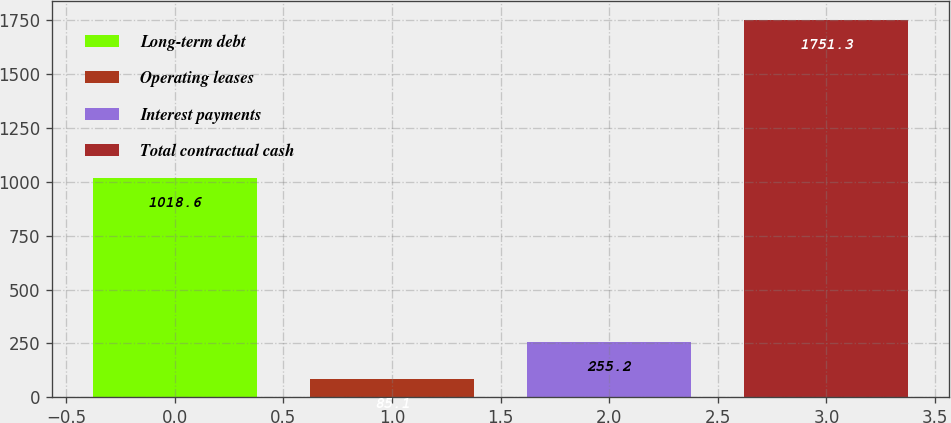Convert chart. <chart><loc_0><loc_0><loc_500><loc_500><bar_chart><fcel>Long-term debt<fcel>Operating leases<fcel>Interest payments<fcel>Total contractual cash<nl><fcel>1018.6<fcel>85.1<fcel>255.2<fcel>1751.3<nl></chart> 